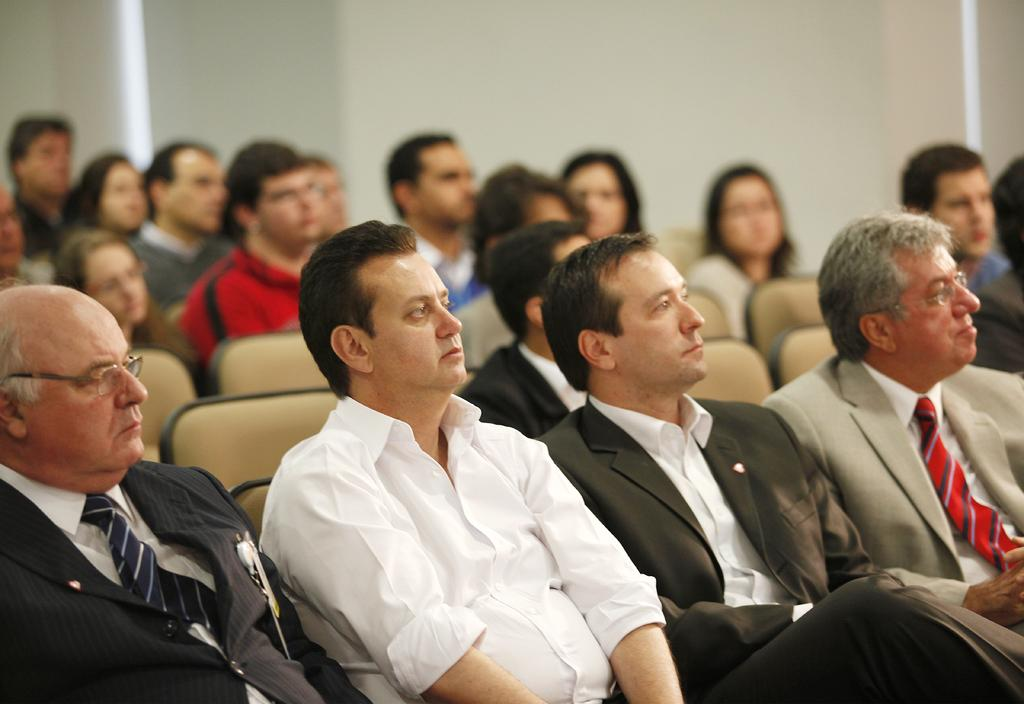What are the people in the image doing? The people in the image are sitting on chairs in the center of the image. What can be seen behind the people? There is a wall in the background of the image. What type of loaf is being served to the people in the image? There is no loaf present in the image; it only shows people sitting on chairs with a wall in the background. 